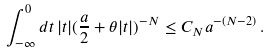Convert formula to latex. <formula><loc_0><loc_0><loc_500><loc_500>\int _ { - \infty } ^ { 0 } d t \, | t | ( \frac { a } { 2 } + \theta | t | ) ^ { - N } \leq C _ { N } a ^ { - ( N - 2 ) } \, .</formula> 